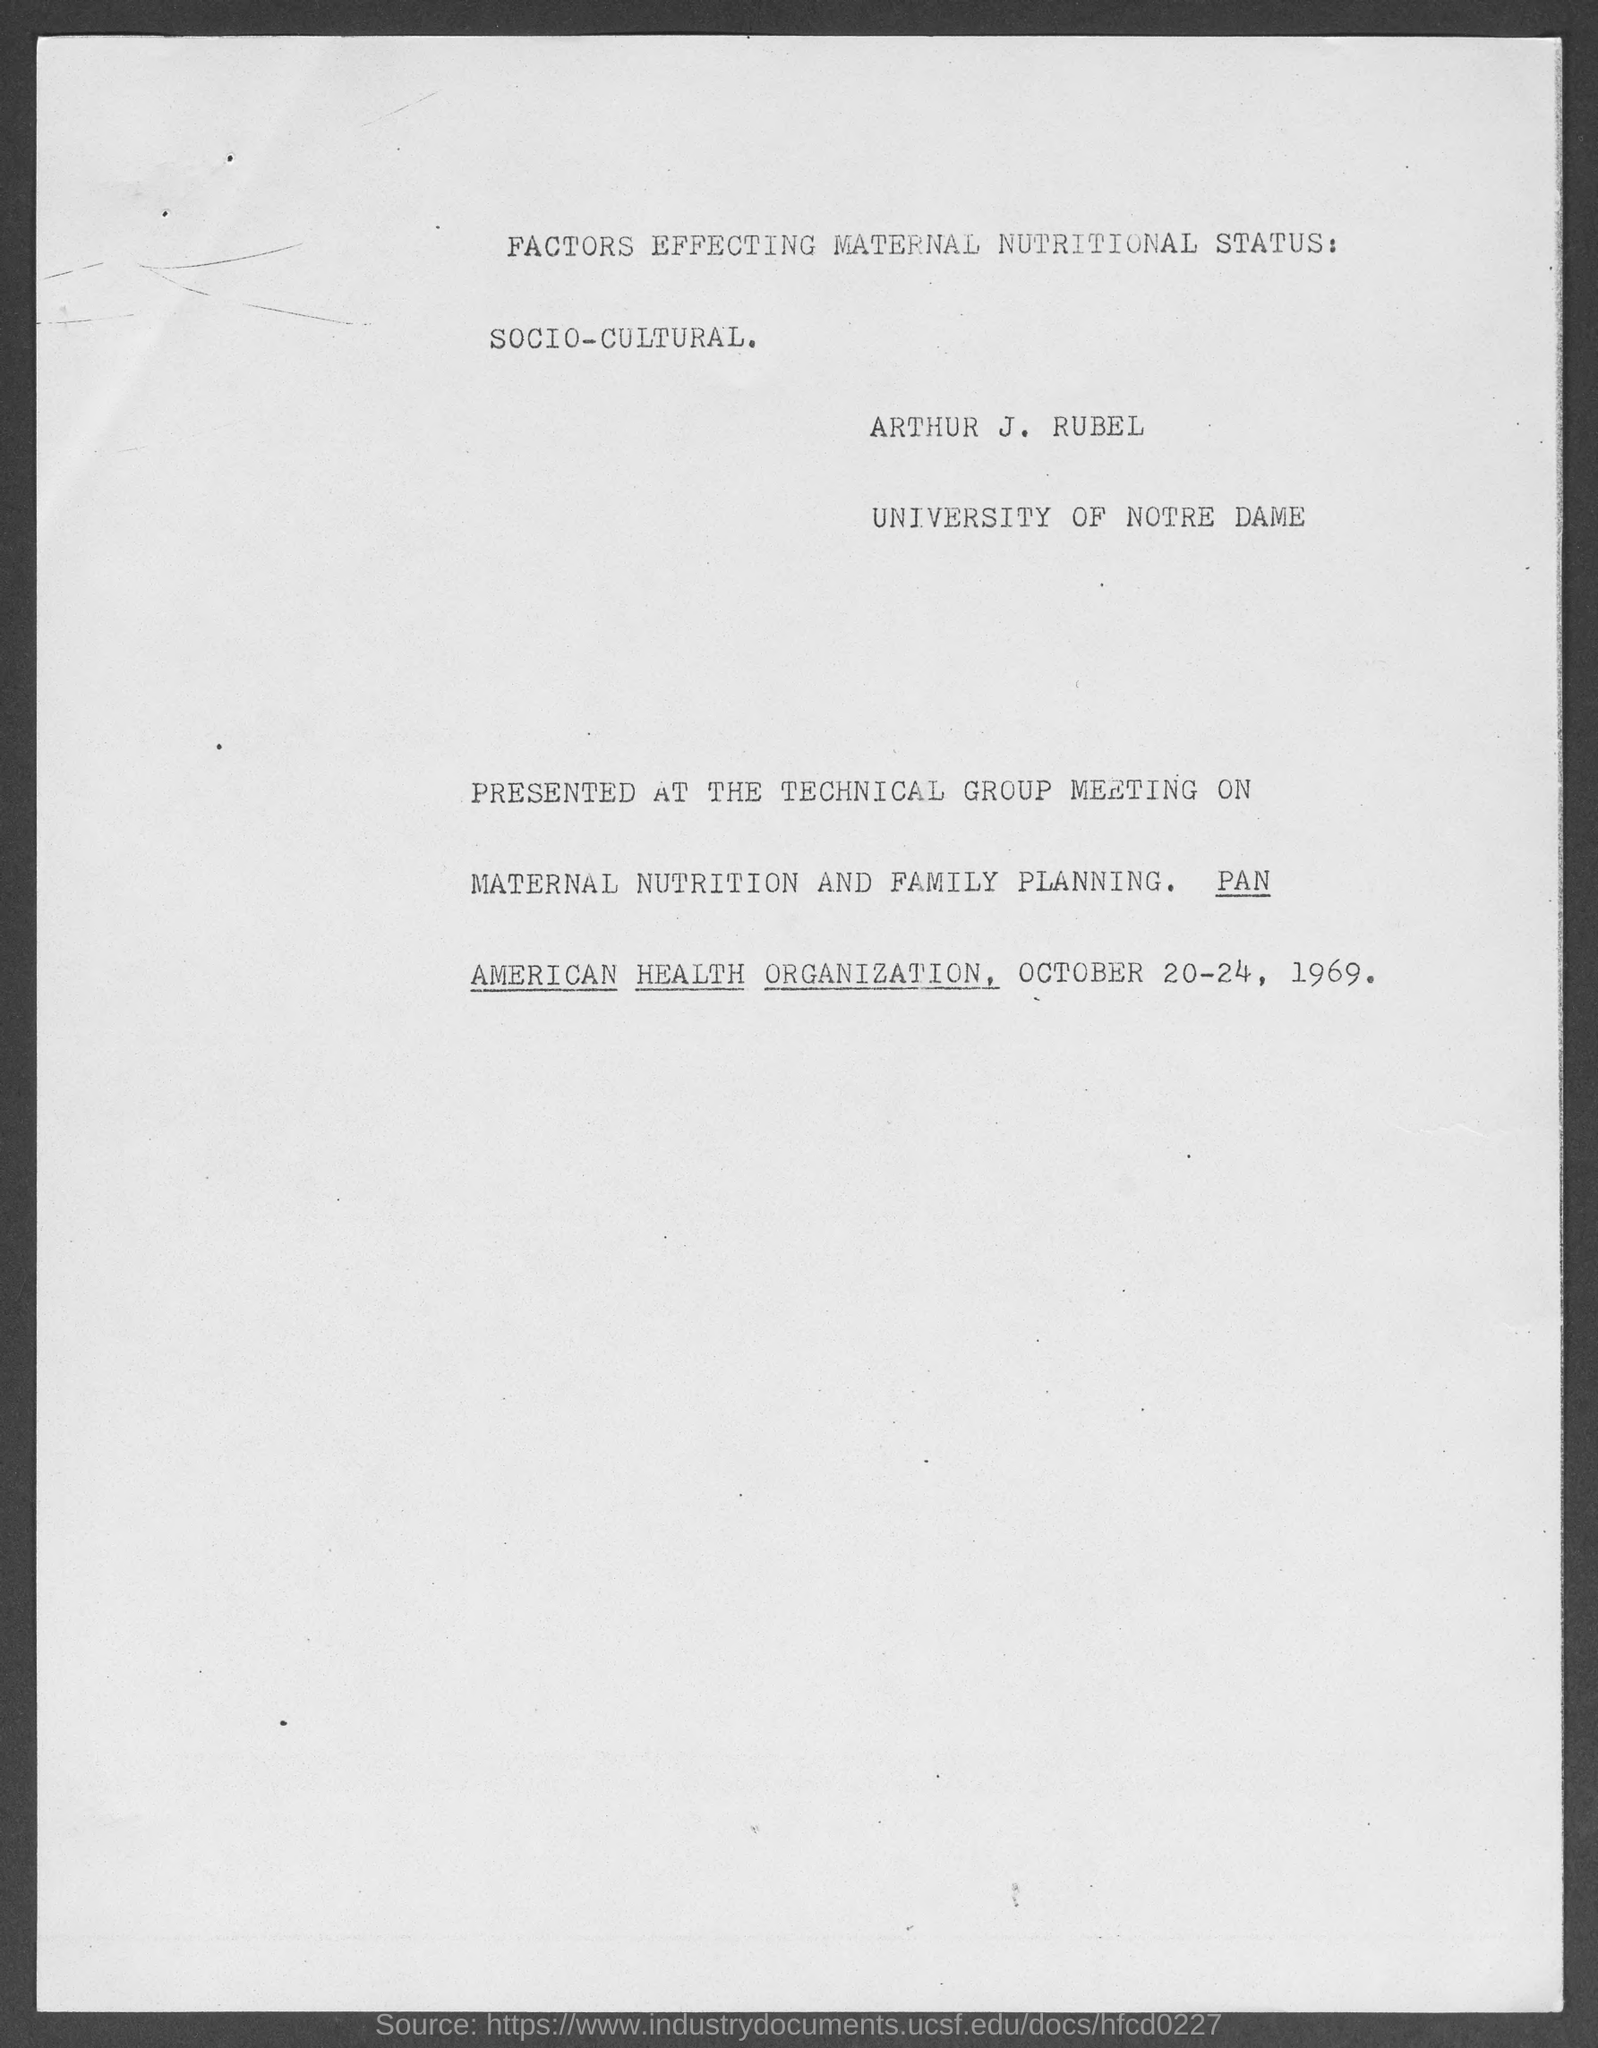List a handful of essential elements in this visual. The University of Notre Dame is the name of the university. The name of the person is Arthur J. Rubel. The date mentioned in the document is October 20-24, 1969. 